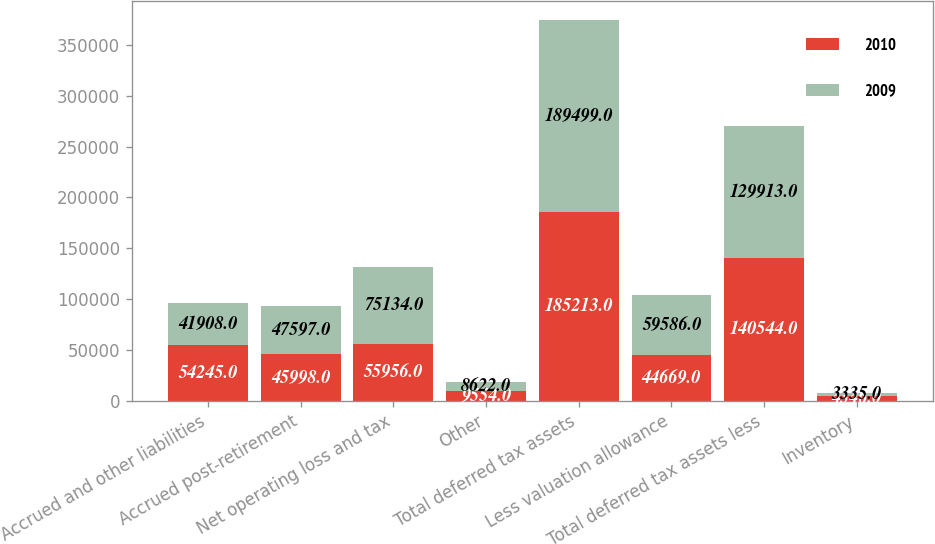<chart> <loc_0><loc_0><loc_500><loc_500><stacked_bar_chart><ecel><fcel>Accrued and other liabilities<fcel>Accrued post-retirement<fcel>Net operating loss and tax<fcel>Other<fcel>Total deferred tax assets<fcel>Less valuation allowance<fcel>Total deferred tax assets less<fcel>Inventory<nl><fcel>2010<fcel>54245<fcel>45998<fcel>55956<fcel>9554<fcel>185213<fcel>44669<fcel>140544<fcel>4346<nl><fcel>2009<fcel>41908<fcel>47597<fcel>75134<fcel>8622<fcel>189499<fcel>59586<fcel>129913<fcel>3335<nl></chart> 